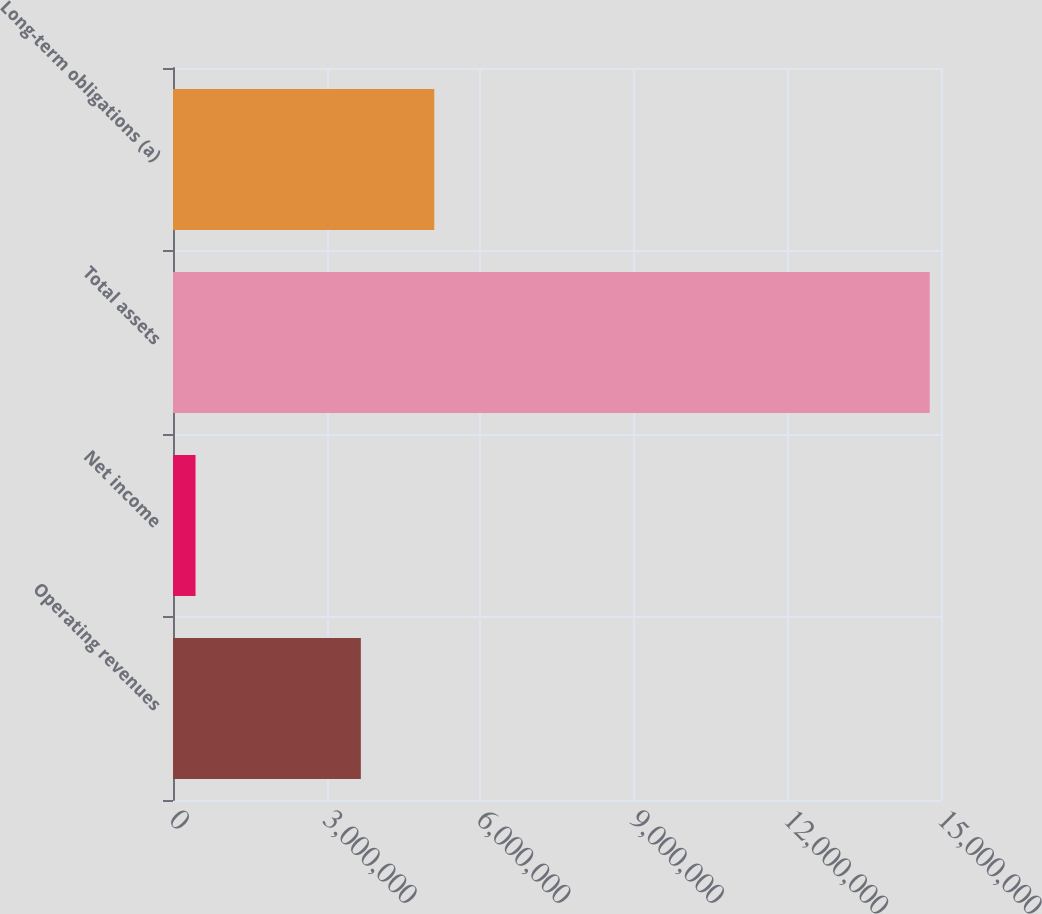<chart> <loc_0><loc_0><loc_500><loc_500><bar_chart><fcel>Operating revenues<fcel>Net income<fcel>Total assets<fcel>Long-term obligations (a)<nl><fcel>3.66876e+06<fcel>440058<fcel>1.47796e+07<fcel>5.10271e+06<nl></chart> 